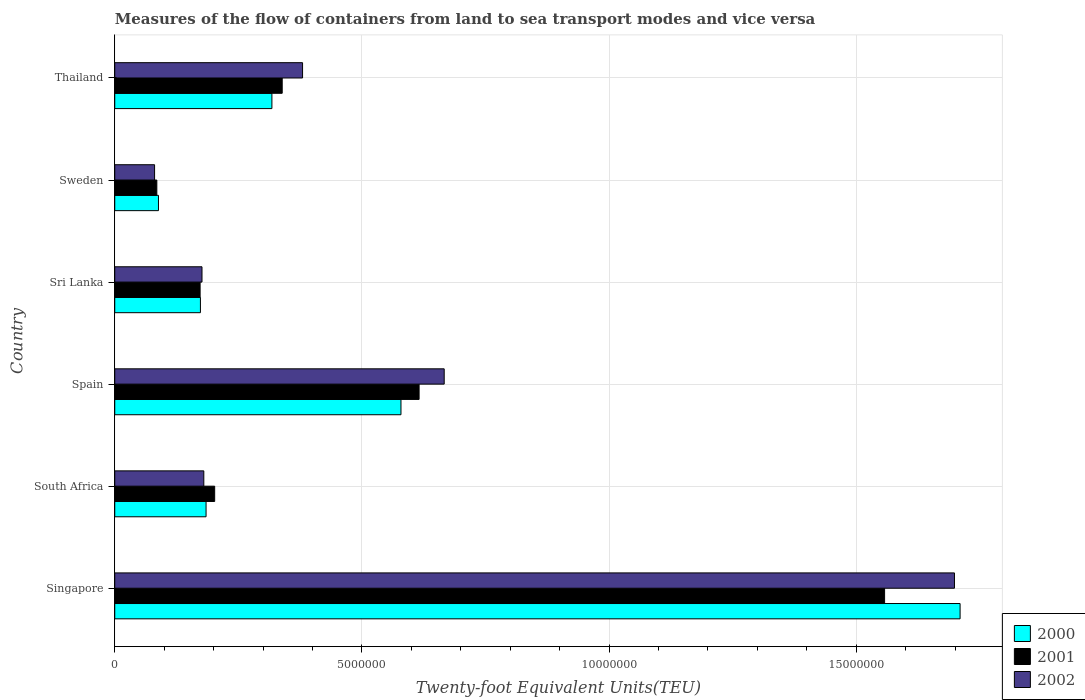Are the number of bars per tick equal to the number of legend labels?
Offer a terse response. Yes. Are the number of bars on each tick of the Y-axis equal?
Provide a short and direct response. Yes. How many bars are there on the 1st tick from the top?
Offer a very short reply. 3. How many bars are there on the 3rd tick from the bottom?
Offer a terse response. 3. What is the label of the 3rd group of bars from the top?
Your response must be concise. Sri Lanka. What is the container port traffic in 2000 in Thailand?
Make the answer very short. 3.18e+06. Across all countries, what is the maximum container port traffic in 2002?
Make the answer very short. 1.70e+07. Across all countries, what is the minimum container port traffic in 2001?
Give a very brief answer. 8.51e+05. In which country was the container port traffic in 2001 maximum?
Ensure brevity in your answer.  Singapore. In which country was the container port traffic in 2002 minimum?
Give a very brief answer. Sweden. What is the total container port traffic in 2002 in the graph?
Offer a very short reply. 3.18e+07. What is the difference between the container port traffic in 2000 in South Africa and that in Sri Lanka?
Offer a very short reply. 1.14e+05. What is the difference between the container port traffic in 2000 in Thailand and the container port traffic in 2002 in Sweden?
Offer a very short reply. 2.37e+06. What is the average container port traffic in 2000 per country?
Keep it short and to the point. 5.09e+06. What is the difference between the container port traffic in 2001 and container port traffic in 2002 in South Africa?
Provide a succinct answer. 2.20e+05. What is the ratio of the container port traffic in 2000 in Singapore to that in Spain?
Your answer should be compact. 2.95. Is the difference between the container port traffic in 2001 in South Africa and Spain greater than the difference between the container port traffic in 2002 in South Africa and Spain?
Your response must be concise. Yes. What is the difference between the highest and the second highest container port traffic in 2001?
Offer a very short reply. 9.42e+06. What is the difference between the highest and the lowest container port traffic in 2002?
Your answer should be compact. 1.62e+07. Is the sum of the container port traffic in 2000 in South Africa and Thailand greater than the maximum container port traffic in 2002 across all countries?
Provide a short and direct response. No. What does the 3rd bar from the bottom in Spain represents?
Offer a very short reply. 2002. What is the difference between two consecutive major ticks on the X-axis?
Your answer should be compact. 5.00e+06. Are the values on the major ticks of X-axis written in scientific E-notation?
Provide a succinct answer. No. Does the graph contain any zero values?
Ensure brevity in your answer.  No. Does the graph contain grids?
Keep it short and to the point. Yes. Where does the legend appear in the graph?
Make the answer very short. Bottom right. How are the legend labels stacked?
Provide a succinct answer. Vertical. What is the title of the graph?
Make the answer very short. Measures of the flow of containers from land to sea transport modes and vice versa. Does "2014" appear as one of the legend labels in the graph?
Offer a very short reply. No. What is the label or title of the X-axis?
Your answer should be compact. Twenty-foot Equivalent Units(TEU). What is the Twenty-foot Equivalent Units(TEU) in 2000 in Singapore?
Make the answer very short. 1.71e+07. What is the Twenty-foot Equivalent Units(TEU) in 2001 in Singapore?
Your answer should be very brief. 1.56e+07. What is the Twenty-foot Equivalent Units(TEU) in 2002 in Singapore?
Keep it short and to the point. 1.70e+07. What is the Twenty-foot Equivalent Units(TEU) of 2000 in South Africa?
Offer a very short reply. 1.85e+06. What is the Twenty-foot Equivalent Units(TEU) of 2001 in South Africa?
Offer a terse response. 2.02e+06. What is the Twenty-foot Equivalent Units(TEU) of 2002 in South Africa?
Provide a short and direct response. 1.80e+06. What is the Twenty-foot Equivalent Units(TEU) in 2000 in Spain?
Ensure brevity in your answer.  5.79e+06. What is the Twenty-foot Equivalent Units(TEU) of 2001 in Spain?
Your response must be concise. 6.16e+06. What is the Twenty-foot Equivalent Units(TEU) of 2002 in Spain?
Your answer should be very brief. 6.66e+06. What is the Twenty-foot Equivalent Units(TEU) in 2000 in Sri Lanka?
Offer a terse response. 1.73e+06. What is the Twenty-foot Equivalent Units(TEU) in 2001 in Sri Lanka?
Offer a very short reply. 1.73e+06. What is the Twenty-foot Equivalent Units(TEU) in 2002 in Sri Lanka?
Your answer should be compact. 1.76e+06. What is the Twenty-foot Equivalent Units(TEU) in 2000 in Sweden?
Give a very brief answer. 8.84e+05. What is the Twenty-foot Equivalent Units(TEU) of 2001 in Sweden?
Provide a succinct answer. 8.51e+05. What is the Twenty-foot Equivalent Units(TEU) in 2002 in Sweden?
Make the answer very short. 8.06e+05. What is the Twenty-foot Equivalent Units(TEU) of 2000 in Thailand?
Your answer should be very brief. 3.18e+06. What is the Twenty-foot Equivalent Units(TEU) in 2001 in Thailand?
Make the answer very short. 3.39e+06. What is the Twenty-foot Equivalent Units(TEU) of 2002 in Thailand?
Provide a short and direct response. 3.80e+06. Across all countries, what is the maximum Twenty-foot Equivalent Units(TEU) in 2000?
Make the answer very short. 1.71e+07. Across all countries, what is the maximum Twenty-foot Equivalent Units(TEU) in 2001?
Offer a terse response. 1.56e+07. Across all countries, what is the maximum Twenty-foot Equivalent Units(TEU) in 2002?
Your response must be concise. 1.70e+07. Across all countries, what is the minimum Twenty-foot Equivalent Units(TEU) in 2000?
Provide a short and direct response. 8.84e+05. Across all countries, what is the minimum Twenty-foot Equivalent Units(TEU) in 2001?
Provide a succinct answer. 8.51e+05. Across all countries, what is the minimum Twenty-foot Equivalent Units(TEU) of 2002?
Give a very brief answer. 8.06e+05. What is the total Twenty-foot Equivalent Units(TEU) of 2000 in the graph?
Offer a very short reply. 3.05e+07. What is the total Twenty-foot Equivalent Units(TEU) of 2001 in the graph?
Keep it short and to the point. 2.97e+07. What is the total Twenty-foot Equivalent Units(TEU) of 2002 in the graph?
Ensure brevity in your answer.  3.18e+07. What is the difference between the Twenty-foot Equivalent Units(TEU) in 2000 in Singapore and that in South Africa?
Your answer should be very brief. 1.53e+07. What is the difference between the Twenty-foot Equivalent Units(TEU) of 2001 in Singapore and that in South Africa?
Make the answer very short. 1.36e+07. What is the difference between the Twenty-foot Equivalent Units(TEU) of 2002 in Singapore and that in South Africa?
Provide a succinct answer. 1.52e+07. What is the difference between the Twenty-foot Equivalent Units(TEU) in 2000 in Singapore and that in Spain?
Give a very brief answer. 1.13e+07. What is the difference between the Twenty-foot Equivalent Units(TEU) in 2001 in Singapore and that in Spain?
Your answer should be very brief. 9.42e+06. What is the difference between the Twenty-foot Equivalent Units(TEU) in 2002 in Singapore and that in Spain?
Your answer should be very brief. 1.03e+07. What is the difference between the Twenty-foot Equivalent Units(TEU) of 2000 in Singapore and that in Sri Lanka?
Offer a very short reply. 1.54e+07. What is the difference between the Twenty-foot Equivalent Units(TEU) of 2001 in Singapore and that in Sri Lanka?
Your answer should be very brief. 1.38e+07. What is the difference between the Twenty-foot Equivalent Units(TEU) of 2002 in Singapore and that in Sri Lanka?
Offer a very short reply. 1.52e+07. What is the difference between the Twenty-foot Equivalent Units(TEU) in 2000 in Singapore and that in Sweden?
Provide a succinct answer. 1.62e+07. What is the difference between the Twenty-foot Equivalent Units(TEU) of 2001 in Singapore and that in Sweden?
Provide a short and direct response. 1.47e+07. What is the difference between the Twenty-foot Equivalent Units(TEU) in 2002 in Singapore and that in Sweden?
Keep it short and to the point. 1.62e+07. What is the difference between the Twenty-foot Equivalent Units(TEU) of 2000 in Singapore and that in Thailand?
Offer a very short reply. 1.39e+07. What is the difference between the Twenty-foot Equivalent Units(TEU) in 2001 in Singapore and that in Thailand?
Offer a terse response. 1.22e+07. What is the difference between the Twenty-foot Equivalent Units(TEU) in 2002 in Singapore and that in Thailand?
Give a very brief answer. 1.32e+07. What is the difference between the Twenty-foot Equivalent Units(TEU) in 2000 in South Africa and that in Spain?
Offer a very short reply. -3.94e+06. What is the difference between the Twenty-foot Equivalent Units(TEU) in 2001 in South Africa and that in Spain?
Keep it short and to the point. -4.14e+06. What is the difference between the Twenty-foot Equivalent Units(TEU) of 2002 in South Africa and that in Spain?
Your answer should be very brief. -4.86e+06. What is the difference between the Twenty-foot Equivalent Units(TEU) of 2000 in South Africa and that in Sri Lanka?
Ensure brevity in your answer.  1.14e+05. What is the difference between the Twenty-foot Equivalent Units(TEU) of 2001 in South Africa and that in Sri Lanka?
Your answer should be very brief. 2.95e+05. What is the difference between the Twenty-foot Equivalent Units(TEU) of 2002 in South Africa and that in Sri Lanka?
Your response must be concise. 3.69e+04. What is the difference between the Twenty-foot Equivalent Units(TEU) of 2000 in South Africa and that in Sweden?
Offer a very short reply. 9.63e+05. What is the difference between the Twenty-foot Equivalent Units(TEU) in 2001 in South Africa and that in Sweden?
Make the answer very short. 1.17e+06. What is the difference between the Twenty-foot Equivalent Units(TEU) in 2002 in South Africa and that in Sweden?
Keep it short and to the point. 9.96e+05. What is the difference between the Twenty-foot Equivalent Units(TEU) of 2000 in South Africa and that in Thailand?
Provide a succinct answer. -1.33e+06. What is the difference between the Twenty-foot Equivalent Units(TEU) in 2001 in South Africa and that in Thailand?
Your response must be concise. -1.37e+06. What is the difference between the Twenty-foot Equivalent Units(TEU) in 2002 in South Africa and that in Thailand?
Ensure brevity in your answer.  -2.00e+06. What is the difference between the Twenty-foot Equivalent Units(TEU) in 2000 in Spain and that in Sri Lanka?
Keep it short and to the point. 4.06e+06. What is the difference between the Twenty-foot Equivalent Units(TEU) of 2001 in Spain and that in Sri Lanka?
Your answer should be very brief. 4.43e+06. What is the difference between the Twenty-foot Equivalent Units(TEU) of 2002 in Spain and that in Sri Lanka?
Offer a very short reply. 4.90e+06. What is the difference between the Twenty-foot Equivalent Units(TEU) in 2000 in Spain and that in Sweden?
Your response must be concise. 4.91e+06. What is the difference between the Twenty-foot Equivalent Units(TEU) in 2001 in Spain and that in Sweden?
Keep it short and to the point. 5.31e+06. What is the difference between the Twenty-foot Equivalent Units(TEU) in 2002 in Spain and that in Sweden?
Your answer should be compact. 5.86e+06. What is the difference between the Twenty-foot Equivalent Units(TEU) in 2000 in Spain and that in Thailand?
Offer a very short reply. 2.61e+06. What is the difference between the Twenty-foot Equivalent Units(TEU) of 2001 in Spain and that in Thailand?
Provide a succinct answer. 2.77e+06. What is the difference between the Twenty-foot Equivalent Units(TEU) of 2002 in Spain and that in Thailand?
Provide a succinct answer. 2.87e+06. What is the difference between the Twenty-foot Equivalent Units(TEU) in 2000 in Sri Lanka and that in Sweden?
Offer a very short reply. 8.49e+05. What is the difference between the Twenty-foot Equivalent Units(TEU) in 2001 in Sri Lanka and that in Sweden?
Ensure brevity in your answer.  8.75e+05. What is the difference between the Twenty-foot Equivalent Units(TEU) in 2002 in Sri Lanka and that in Sweden?
Offer a very short reply. 9.59e+05. What is the difference between the Twenty-foot Equivalent Units(TEU) in 2000 in Sri Lanka and that in Thailand?
Ensure brevity in your answer.  -1.45e+06. What is the difference between the Twenty-foot Equivalent Units(TEU) of 2001 in Sri Lanka and that in Thailand?
Give a very brief answer. -1.66e+06. What is the difference between the Twenty-foot Equivalent Units(TEU) of 2002 in Sri Lanka and that in Thailand?
Keep it short and to the point. -2.03e+06. What is the difference between the Twenty-foot Equivalent Units(TEU) of 2000 in Sweden and that in Thailand?
Provide a short and direct response. -2.29e+06. What is the difference between the Twenty-foot Equivalent Units(TEU) in 2001 in Sweden and that in Thailand?
Your response must be concise. -2.54e+06. What is the difference between the Twenty-foot Equivalent Units(TEU) in 2002 in Sweden and that in Thailand?
Your answer should be very brief. -2.99e+06. What is the difference between the Twenty-foot Equivalent Units(TEU) of 2000 in Singapore and the Twenty-foot Equivalent Units(TEU) of 2001 in South Africa?
Your response must be concise. 1.51e+07. What is the difference between the Twenty-foot Equivalent Units(TEU) of 2000 in Singapore and the Twenty-foot Equivalent Units(TEU) of 2002 in South Africa?
Your answer should be very brief. 1.53e+07. What is the difference between the Twenty-foot Equivalent Units(TEU) in 2001 in Singapore and the Twenty-foot Equivalent Units(TEU) in 2002 in South Africa?
Make the answer very short. 1.38e+07. What is the difference between the Twenty-foot Equivalent Units(TEU) in 2000 in Singapore and the Twenty-foot Equivalent Units(TEU) in 2001 in Spain?
Keep it short and to the point. 1.09e+07. What is the difference between the Twenty-foot Equivalent Units(TEU) of 2000 in Singapore and the Twenty-foot Equivalent Units(TEU) of 2002 in Spain?
Your response must be concise. 1.04e+07. What is the difference between the Twenty-foot Equivalent Units(TEU) in 2001 in Singapore and the Twenty-foot Equivalent Units(TEU) in 2002 in Spain?
Provide a succinct answer. 8.91e+06. What is the difference between the Twenty-foot Equivalent Units(TEU) in 2000 in Singapore and the Twenty-foot Equivalent Units(TEU) in 2001 in Sri Lanka?
Keep it short and to the point. 1.54e+07. What is the difference between the Twenty-foot Equivalent Units(TEU) of 2000 in Singapore and the Twenty-foot Equivalent Units(TEU) of 2002 in Sri Lanka?
Your answer should be very brief. 1.53e+07. What is the difference between the Twenty-foot Equivalent Units(TEU) of 2001 in Singapore and the Twenty-foot Equivalent Units(TEU) of 2002 in Sri Lanka?
Your response must be concise. 1.38e+07. What is the difference between the Twenty-foot Equivalent Units(TEU) of 2000 in Singapore and the Twenty-foot Equivalent Units(TEU) of 2001 in Sweden?
Provide a succinct answer. 1.62e+07. What is the difference between the Twenty-foot Equivalent Units(TEU) in 2000 in Singapore and the Twenty-foot Equivalent Units(TEU) in 2002 in Sweden?
Provide a short and direct response. 1.63e+07. What is the difference between the Twenty-foot Equivalent Units(TEU) in 2001 in Singapore and the Twenty-foot Equivalent Units(TEU) in 2002 in Sweden?
Give a very brief answer. 1.48e+07. What is the difference between the Twenty-foot Equivalent Units(TEU) of 2000 in Singapore and the Twenty-foot Equivalent Units(TEU) of 2001 in Thailand?
Offer a very short reply. 1.37e+07. What is the difference between the Twenty-foot Equivalent Units(TEU) of 2000 in Singapore and the Twenty-foot Equivalent Units(TEU) of 2002 in Thailand?
Ensure brevity in your answer.  1.33e+07. What is the difference between the Twenty-foot Equivalent Units(TEU) of 2001 in Singapore and the Twenty-foot Equivalent Units(TEU) of 2002 in Thailand?
Your answer should be compact. 1.18e+07. What is the difference between the Twenty-foot Equivalent Units(TEU) in 2000 in South Africa and the Twenty-foot Equivalent Units(TEU) in 2001 in Spain?
Make the answer very short. -4.31e+06. What is the difference between the Twenty-foot Equivalent Units(TEU) of 2000 in South Africa and the Twenty-foot Equivalent Units(TEU) of 2002 in Spain?
Give a very brief answer. -4.82e+06. What is the difference between the Twenty-foot Equivalent Units(TEU) of 2001 in South Africa and the Twenty-foot Equivalent Units(TEU) of 2002 in Spain?
Offer a very short reply. -4.64e+06. What is the difference between the Twenty-foot Equivalent Units(TEU) in 2000 in South Africa and the Twenty-foot Equivalent Units(TEU) in 2001 in Sri Lanka?
Make the answer very short. 1.20e+05. What is the difference between the Twenty-foot Equivalent Units(TEU) in 2000 in South Africa and the Twenty-foot Equivalent Units(TEU) in 2002 in Sri Lanka?
Keep it short and to the point. 8.22e+04. What is the difference between the Twenty-foot Equivalent Units(TEU) of 2001 in South Africa and the Twenty-foot Equivalent Units(TEU) of 2002 in Sri Lanka?
Keep it short and to the point. 2.56e+05. What is the difference between the Twenty-foot Equivalent Units(TEU) in 2000 in South Africa and the Twenty-foot Equivalent Units(TEU) in 2001 in Sweden?
Your response must be concise. 9.96e+05. What is the difference between the Twenty-foot Equivalent Units(TEU) of 2000 in South Africa and the Twenty-foot Equivalent Units(TEU) of 2002 in Sweden?
Give a very brief answer. 1.04e+06. What is the difference between the Twenty-foot Equivalent Units(TEU) in 2001 in South Africa and the Twenty-foot Equivalent Units(TEU) in 2002 in Sweden?
Provide a succinct answer. 1.22e+06. What is the difference between the Twenty-foot Equivalent Units(TEU) of 2000 in South Africa and the Twenty-foot Equivalent Units(TEU) of 2001 in Thailand?
Make the answer very short. -1.54e+06. What is the difference between the Twenty-foot Equivalent Units(TEU) in 2000 in South Africa and the Twenty-foot Equivalent Units(TEU) in 2002 in Thailand?
Make the answer very short. -1.95e+06. What is the difference between the Twenty-foot Equivalent Units(TEU) in 2001 in South Africa and the Twenty-foot Equivalent Units(TEU) in 2002 in Thailand?
Offer a terse response. -1.78e+06. What is the difference between the Twenty-foot Equivalent Units(TEU) of 2000 in Spain and the Twenty-foot Equivalent Units(TEU) of 2001 in Sri Lanka?
Your response must be concise. 4.06e+06. What is the difference between the Twenty-foot Equivalent Units(TEU) in 2000 in Spain and the Twenty-foot Equivalent Units(TEU) in 2002 in Sri Lanka?
Offer a very short reply. 4.02e+06. What is the difference between the Twenty-foot Equivalent Units(TEU) of 2001 in Spain and the Twenty-foot Equivalent Units(TEU) of 2002 in Sri Lanka?
Keep it short and to the point. 4.39e+06. What is the difference between the Twenty-foot Equivalent Units(TEU) in 2000 in Spain and the Twenty-foot Equivalent Units(TEU) in 2001 in Sweden?
Offer a terse response. 4.94e+06. What is the difference between the Twenty-foot Equivalent Units(TEU) of 2000 in Spain and the Twenty-foot Equivalent Units(TEU) of 2002 in Sweden?
Give a very brief answer. 4.98e+06. What is the difference between the Twenty-foot Equivalent Units(TEU) of 2001 in Spain and the Twenty-foot Equivalent Units(TEU) of 2002 in Sweden?
Ensure brevity in your answer.  5.35e+06. What is the difference between the Twenty-foot Equivalent Units(TEU) of 2000 in Spain and the Twenty-foot Equivalent Units(TEU) of 2001 in Thailand?
Offer a very short reply. 2.40e+06. What is the difference between the Twenty-foot Equivalent Units(TEU) in 2000 in Spain and the Twenty-foot Equivalent Units(TEU) in 2002 in Thailand?
Your response must be concise. 1.99e+06. What is the difference between the Twenty-foot Equivalent Units(TEU) in 2001 in Spain and the Twenty-foot Equivalent Units(TEU) in 2002 in Thailand?
Give a very brief answer. 2.36e+06. What is the difference between the Twenty-foot Equivalent Units(TEU) in 2000 in Sri Lanka and the Twenty-foot Equivalent Units(TEU) in 2001 in Sweden?
Your response must be concise. 8.82e+05. What is the difference between the Twenty-foot Equivalent Units(TEU) of 2000 in Sri Lanka and the Twenty-foot Equivalent Units(TEU) of 2002 in Sweden?
Your response must be concise. 9.27e+05. What is the difference between the Twenty-foot Equivalent Units(TEU) of 2001 in Sri Lanka and the Twenty-foot Equivalent Units(TEU) of 2002 in Sweden?
Offer a terse response. 9.21e+05. What is the difference between the Twenty-foot Equivalent Units(TEU) in 2000 in Sri Lanka and the Twenty-foot Equivalent Units(TEU) in 2001 in Thailand?
Provide a succinct answer. -1.65e+06. What is the difference between the Twenty-foot Equivalent Units(TEU) in 2000 in Sri Lanka and the Twenty-foot Equivalent Units(TEU) in 2002 in Thailand?
Provide a succinct answer. -2.07e+06. What is the difference between the Twenty-foot Equivalent Units(TEU) of 2001 in Sri Lanka and the Twenty-foot Equivalent Units(TEU) of 2002 in Thailand?
Keep it short and to the point. -2.07e+06. What is the difference between the Twenty-foot Equivalent Units(TEU) in 2000 in Sweden and the Twenty-foot Equivalent Units(TEU) in 2001 in Thailand?
Offer a terse response. -2.50e+06. What is the difference between the Twenty-foot Equivalent Units(TEU) of 2000 in Sweden and the Twenty-foot Equivalent Units(TEU) of 2002 in Thailand?
Your answer should be compact. -2.91e+06. What is the difference between the Twenty-foot Equivalent Units(TEU) in 2001 in Sweden and the Twenty-foot Equivalent Units(TEU) in 2002 in Thailand?
Your answer should be compact. -2.95e+06. What is the average Twenty-foot Equivalent Units(TEU) in 2000 per country?
Provide a succinct answer. 5.09e+06. What is the average Twenty-foot Equivalent Units(TEU) of 2001 per country?
Provide a short and direct response. 4.95e+06. What is the average Twenty-foot Equivalent Units(TEU) in 2002 per country?
Offer a very short reply. 5.30e+06. What is the difference between the Twenty-foot Equivalent Units(TEU) in 2000 and Twenty-foot Equivalent Units(TEU) in 2001 in Singapore?
Provide a succinct answer. 1.53e+06. What is the difference between the Twenty-foot Equivalent Units(TEU) in 2000 and Twenty-foot Equivalent Units(TEU) in 2002 in Singapore?
Your answer should be compact. 1.14e+05. What is the difference between the Twenty-foot Equivalent Units(TEU) in 2001 and Twenty-foot Equivalent Units(TEU) in 2002 in Singapore?
Your answer should be very brief. -1.41e+06. What is the difference between the Twenty-foot Equivalent Units(TEU) of 2000 and Twenty-foot Equivalent Units(TEU) of 2001 in South Africa?
Offer a very short reply. -1.74e+05. What is the difference between the Twenty-foot Equivalent Units(TEU) of 2000 and Twenty-foot Equivalent Units(TEU) of 2002 in South Africa?
Ensure brevity in your answer.  4.53e+04. What is the difference between the Twenty-foot Equivalent Units(TEU) in 2001 and Twenty-foot Equivalent Units(TEU) in 2002 in South Africa?
Your answer should be very brief. 2.20e+05. What is the difference between the Twenty-foot Equivalent Units(TEU) of 2000 and Twenty-foot Equivalent Units(TEU) of 2001 in Spain?
Make the answer very short. -3.67e+05. What is the difference between the Twenty-foot Equivalent Units(TEU) of 2000 and Twenty-foot Equivalent Units(TEU) of 2002 in Spain?
Your answer should be compact. -8.74e+05. What is the difference between the Twenty-foot Equivalent Units(TEU) of 2001 and Twenty-foot Equivalent Units(TEU) of 2002 in Spain?
Your answer should be very brief. -5.08e+05. What is the difference between the Twenty-foot Equivalent Units(TEU) of 2000 and Twenty-foot Equivalent Units(TEU) of 2001 in Sri Lanka?
Offer a terse response. 6250. What is the difference between the Twenty-foot Equivalent Units(TEU) of 2000 and Twenty-foot Equivalent Units(TEU) of 2002 in Sri Lanka?
Offer a very short reply. -3.19e+04. What is the difference between the Twenty-foot Equivalent Units(TEU) in 2001 and Twenty-foot Equivalent Units(TEU) in 2002 in Sri Lanka?
Keep it short and to the point. -3.81e+04. What is the difference between the Twenty-foot Equivalent Units(TEU) of 2000 and Twenty-foot Equivalent Units(TEU) of 2001 in Sweden?
Ensure brevity in your answer.  3.29e+04. What is the difference between the Twenty-foot Equivalent Units(TEU) of 2000 and Twenty-foot Equivalent Units(TEU) of 2002 in Sweden?
Your response must be concise. 7.85e+04. What is the difference between the Twenty-foot Equivalent Units(TEU) in 2001 and Twenty-foot Equivalent Units(TEU) in 2002 in Sweden?
Give a very brief answer. 4.56e+04. What is the difference between the Twenty-foot Equivalent Units(TEU) of 2000 and Twenty-foot Equivalent Units(TEU) of 2001 in Thailand?
Offer a very short reply. -2.08e+05. What is the difference between the Twenty-foot Equivalent Units(TEU) in 2000 and Twenty-foot Equivalent Units(TEU) in 2002 in Thailand?
Make the answer very short. -6.20e+05. What is the difference between the Twenty-foot Equivalent Units(TEU) of 2001 and Twenty-foot Equivalent Units(TEU) of 2002 in Thailand?
Provide a short and direct response. -4.12e+05. What is the ratio of the Twenty-foot Equivalent Units(TEU) of 2000 in Singapore to that in South Africa?
Offer a very short reply. 9.26. What is the ratio of the Twenty-foot Equivalent Units(TEU) of 2001 in Singapore to that in South Africa?
Your answer should be very brief. 7.7. What is the ratio of the Twenty-foot Equivalent Units(TEU) in 2002 in Singapore to that in South Africa?
Provide a short and direct response. 9.43. What is the ratio of the Twenty-foot Equivalent Units(TEU) in 2000 in Singapore to that in Spain?
Give a very brief answer. 2.95. What is the ratio of the Twenty-foot Equivalent Units(TEU) of 2001 in Singapore to that in Spain?
Ensure brevity in your answer.  2.53. What is the ratio of the Twenty-foot Equivalent Units(TEU) of 2002 in Singapore to that in Spain?
Make the answer very short. 2.55. What is the ratio of the Twenty-foot Equivalent Units(TEU) of 2000 in Singapore to that in Sri Lanka?
Your answer should be very brief. 9.87. What is the ratio of the Twenty-foot Equivalent Units(TEU) of 2001 in Singapore to that in Sri Lanka?
Offer a terse response. 9.02. What is the ratio of the Twenty-foot Equivalent Units(TEU) of 2002 in Singapore to that in Sri Lanka?
Ensure brevity in your answer.  9.63. What is the ratio of the Twenty-foot Equivalent Units(TEU) of 2000 in Singapore to that in Sweden?
Your response must be concise. 19.34. What is the ratio of the Twenty-foot Equivalent Units(TEU) in 2001 in Singapore to that in Sweden?
Your answer should be very brief. 18.29. What is the ratio of the Twenty-foot Equivalent Units(TEU) in 2002 in Singapore to that in Sweden?
Give a very brief answer. 21.08. What is the ratio of the Twenty-foot Equivalent Units(TEU) in 2000 in Singapore to that in Thailand?
Give a very brief answer. 5.38. What is the ratio of the Twenty-foot Equivalent Units(TEU) in 2001 in Singapore to that in Thailand?
Your answer should be compact. 4.6. What is the ratio of the Twenty-foot Equivalent Units(TEU) in 2002 in Singapore to that in Thailand?
Your answer should be very brief. 4.47. What is the ratio of the Twenty-foot Equivalent Units(TEU) in 2000 in South Africa to that in Spain?
Offer a terse response. 0.32. What is the ratio of the Twenty-foot Equivalent Units(TEU) of 2001 in South Africa to that in Spain?
Your answer should be very brief. 0.33. What is the ratio of the Twenty-foot Equivalent Units(TEU) in 2002 in South Africa to that in Spain?
Provide a succinct answer. 0.27. What is the ratio of the Twenty-foot Equivalent Units(TEU) of 2000 in South Africa to that in Sri Lanka?
Your answer should be very brief. 1.07. What is the ratio of the Twenty-foot Equivalent Units(TEU) in 2001 in South Africa to that in Sri Lanka?
Provide a short and direct response. 1.17. What is the ratio of the Twenty-foot Equivalent Units(TEU) in 2002 in South Africa to that in Sri Lanka?
Your response must be concise. 1.02. What is the ratio of the Twenty-foot Equivalent Units(TEU) in 2000 in South Africa to that in Sweden?
Ensure brevity in your answer.  2.09. What is the ratio of the Twenty-foot Equivalent Units(TEU) in 2001 in South Africa to that in Sweden?
Ensure brevity in your answer.  2.37. What is the ratio of the Twenty-foot Equivalent Units(TEU) in 2002 in South Africa to that in Sweden?
Keep it short and to the point. 2.24. What is the ratio of the Twenty-foot Equivalent Units(TEU) in 2000 in South Africa to that in Thailand?
Keep it short and to the point. 0.58. What is the ratio of the Twenty-foot Equivalent Units(TEU) in 2001 in South Africa to that in Thailand?
Offer a terse response. 0.6. What is the ratio of the Twenty-foot Equivalent Units(TEU) of 2002 in South Africa to that in Thailand?
Offer a terse response. 0.47. What is the ratio of the Twenty-foot Equivalent Units(TEU) of 2000 in Spain to that in Sri Lanka?
Provide a short and direct response. 3.34. What is the ratio of the Twenty-foot Equivalent Units(TEU) of 2001 in Spain to that in Sri Lanka?
Make the answer very short. 3.57. What is the ratio of the Twenty-foot Equivalent Units(TEU) of 2002 in Spain to that in Sri Lanka?
Keep it short and to the point. 3.78. What is the ratio of the Twenty-foot Equivalent Units(TEU) of 2000 in Spain to that in Sweden?
Make the answer very short. 6.55. What is the ratio of the Twenty-foot Equivalent Units(TEU) of 2001 in Spain to that in Sweden?
Offer a very short reply. 7.23. What is the ratio of the Twenty-foot Equivalent Units(TEU) in 2002 in Spain to that in Sweden?
Ensure brevity in your answer.  8.27. What is the ratio of the Twenty-foot Equivalent Units(TEU) of 2000 in Spain to that in Thailand?
Keep it short and to the point. 1.82. What is the ratio of the Twenty-foot Equivalent Units(TEU) in 2001 in Spain to that in Thailand?
Offer a terse response. 1.82. What is the ratio of the Twenty-foot Equivalent Units(TEU) in 2002 in Spain to that in Thailand?
Your answer should be very brief. 1.75. What is the ratio of the Twenty-foot Equivalent Units(TEU) of 2000 in Sri Lanka to that in Sweden?
Offer a terse response. 1.96. What is the ratio of the Twenty-foot Equivalent Units(TEU) of 2001 in Sri Lanka to that in Sweden?
Provide a succinct answer. 2.03. What is the ratio of the Twenty-foot Equivalent Units(TEU) in 2002 in Sri Lanka to that in Sweden?
Ensure brevity in your answer.  2.19. What is the ratio of the Twenty-foot Equivalent Units(TEU) of 2000 in Sri Lanka to that in Thailand?
Your answer should be compact. 0.55. What is the ratio of the Twenty-foot Equivalent Units(TEU) of 2001 in Sri Lanka to that in Thailand?
Your response must be concise. 0.51. What is the ratio of the Twenty-foot Equivalent Units(TEU) of 2002 in Sri Lanka to that in Thailand?
Give a very brief answer. 0.46. What is the ratio of the Twenty-foot Equivalent Units(TEU) in 2000 in Sweden to that in Thailand?
Keep it short and to the point. 0.28. What is the ratio of the Twenty-foot Equivalent Units(TEU) of 2001 in Sweden to that in Thailand?
Your answer should be compact. 0.25. What is the ratio of the Twenty-foot Equivalent Units(TEU) in 2002 in Sweden to that in Thailand?
Your response must be concise. 0.21. What is the difference between the highest and the second highest Twenty-foot Equivalent Units(TEU) in 2000?
Your response must be concise. 1.13e+07. What is the difference between the highest and the second highest Twenty-foot Equivalent Units(TEU) of 2001?
Provide a succinct answer. 9.42e+06. What is the difference between the highest and the second highest Twenty-foot Equivalent Units(TEU) of 2002?
Your answer should be very brief. 1.03e+07. What is the difference between the highest and the lowest Twenty-foot Equivalent Units(TEU) in 2000?
Make the answer very short. 1.62e+07. What is the difference between the highest and the lowest Twenty-foot Equivalent Units(TEU) in 2001?
Make the answer very short. 1.47e+07. What is the difference between the highest and the lowest Twenty-foot Equivalent Units(TEU) in 2002?
Offer a very short reply. 1.62e+07. 